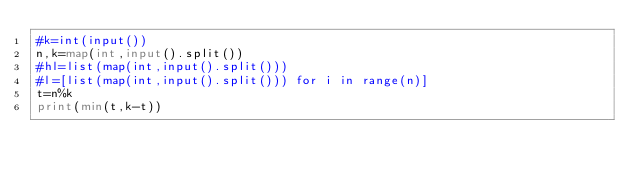Convert code to text. <code><loc_0><loc_0><loc_500><loc_500><_Python_>#k=int(input())
n,k=map(int,input().split())
#hl=list(map(int,input().split()))
#l=[list(map(int,input().split())) for i in range(n)]
t=n%k
print(min(t,k-t))

</code> 